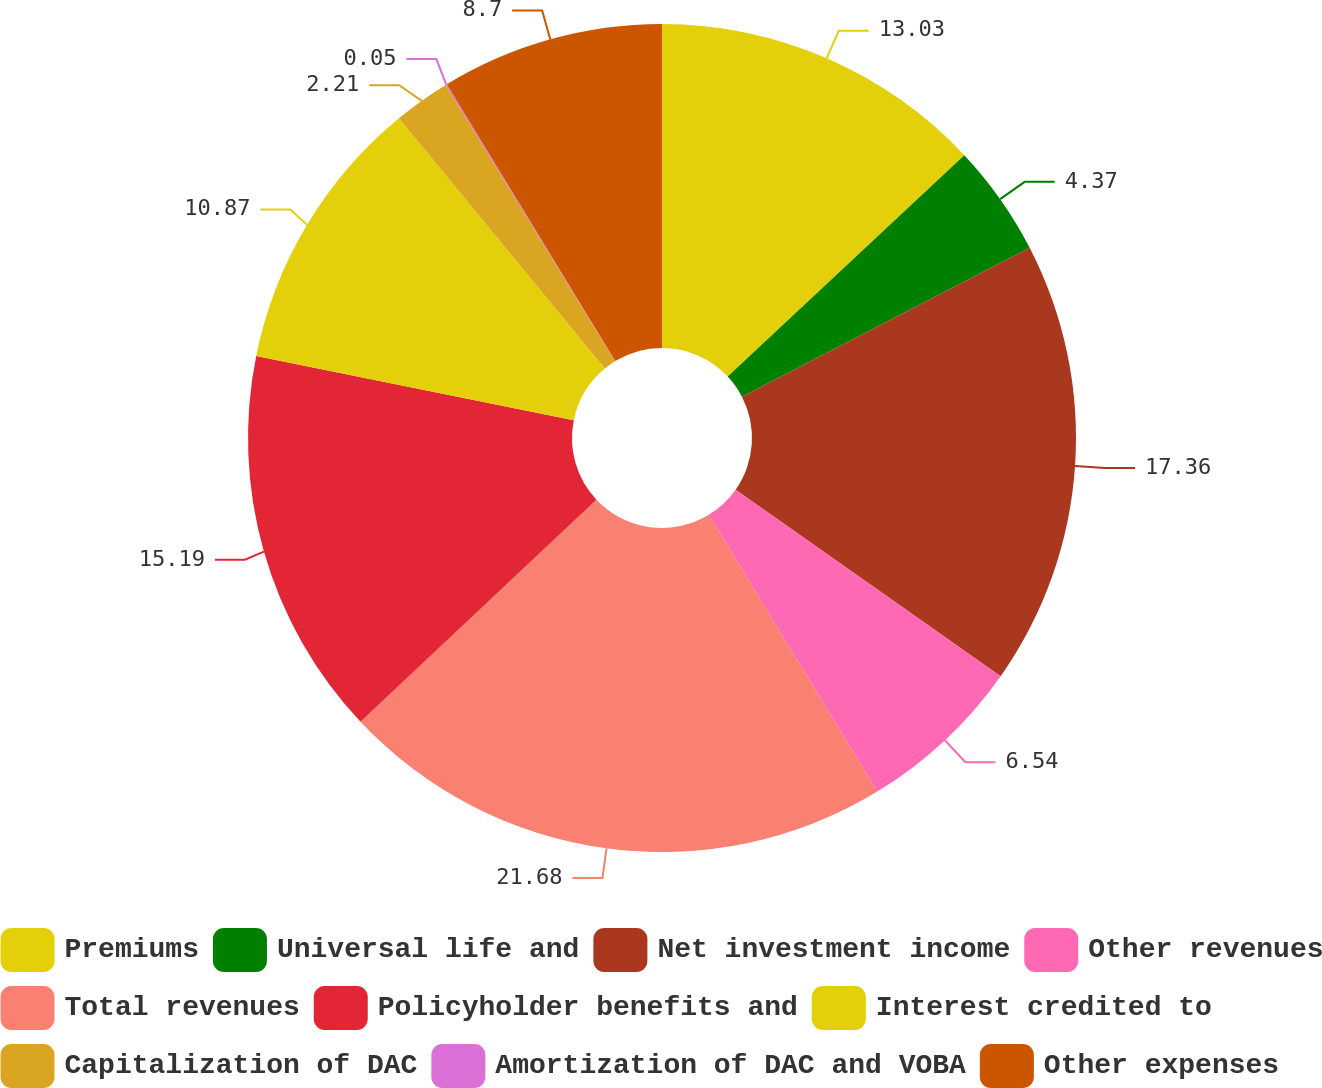Convert chart to OTSL. <chart><loc_0><loc_0><loc_500><loc_500><pie_chart><fcel>Premiums<fcel>Universal life and<fcel>Net investment income<fcel>Other revenues<fcel>Total revenues<fcel>Policyholder benefits and<fcel>Interest credited to<fcel>Capitalization of DAC<fcel>Amortization of DAC and VOBA<fcel>Other expenses<nl><fcel>13.03%<fcel>4.37%<fcel>17.36%<fcel>6.54%<fcel>21.69%<fcel>15.19%<fcel>10.87%<fcel>2.21%<fcel>0.05%<fcel>8.7%<nl></chart> 